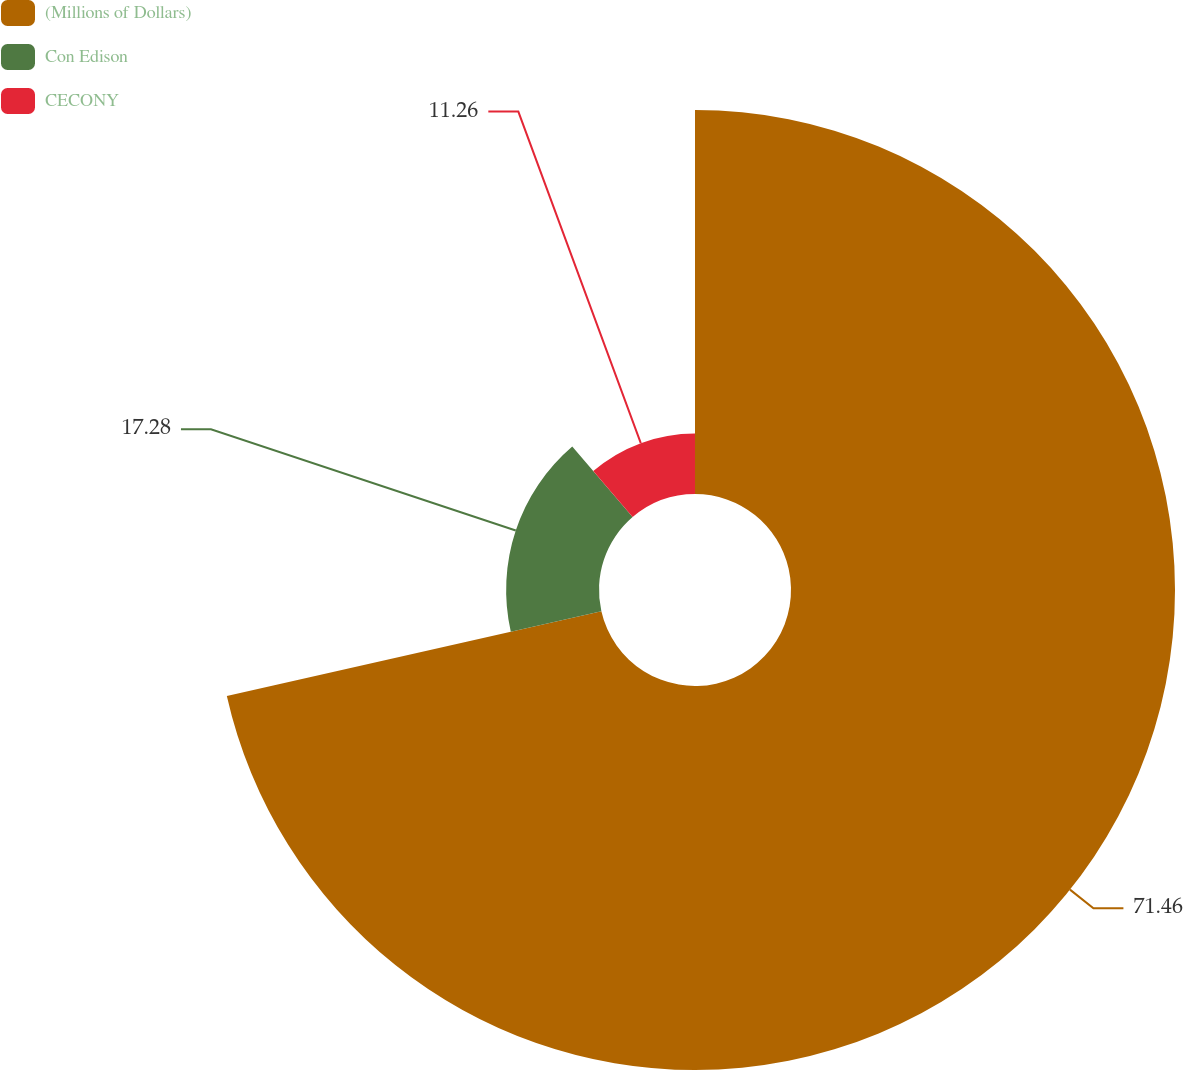Convert chart to OTSL. <chart><loc_0><loc_0><loc_500><loc_500><pie_chart><fcel>(Millions of Dollars)<fcel>Con Edison<fcel>CECONY<nl><fcel>71.46%<fcel>17.28%<fcel>11.26%<nl></chart> 